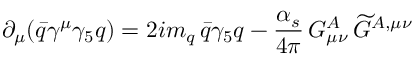Convert formula to latex. <formula><loc_0><loc_0><loc_500><loc_500>\partial _ { \mu } ( \bar { q } \gamma ^ { \mu } \gamma _ { 5 } q ) = 2 i m _ { q } \, \bar { q } \gamma _ { 5 } q - \frac { \alpha _ { s } } { 4 \pi } \, G _ { \mu \nu } ^ { A } \, \widetilde { G } ^ { A , \mu \nu }</formula> 